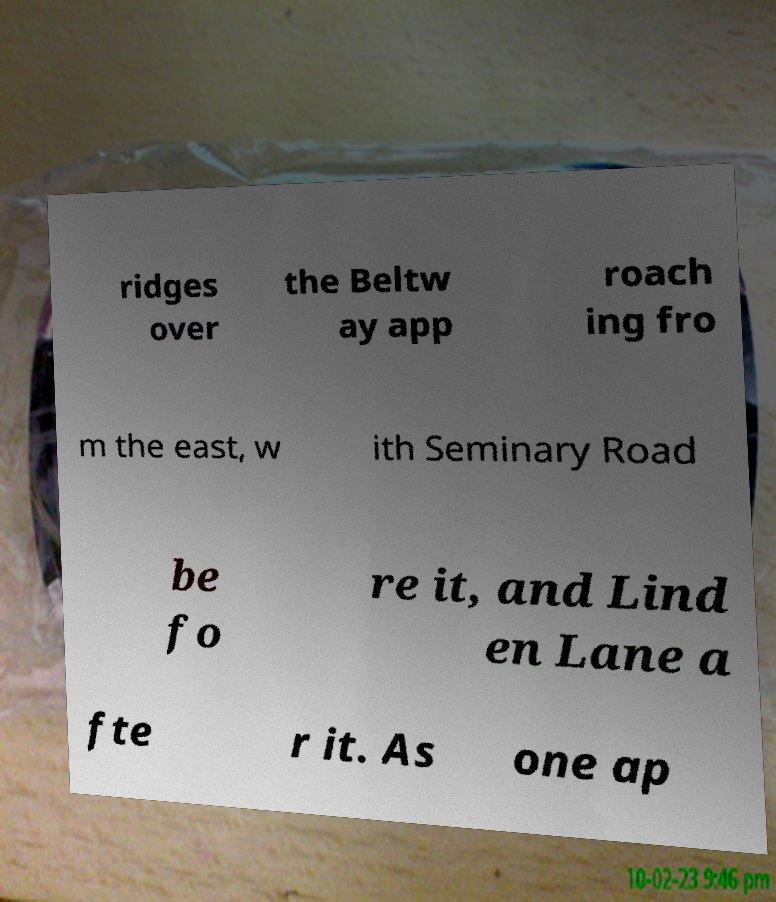Please identify and transcribe the text found in this image. ridges over the Beltw ay app roach ing fro m the east, w ith Seminary Road be fo re it, and Lind en Lane a fte r it. As one ap 